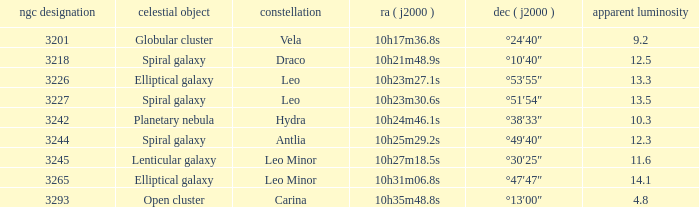What is the total of Apparent magnitudes for an NGC number larger than 3293? None. 